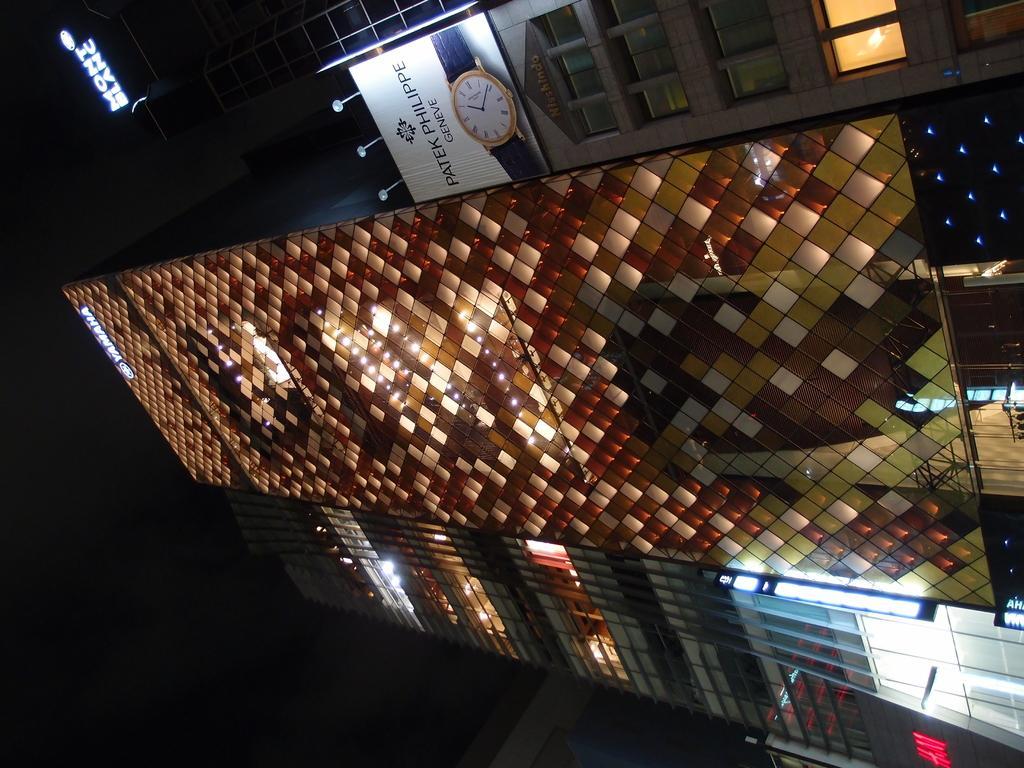How would you summarize this image in a sentence or two? In this image we can see buildings, electric lights, name board and an advertisement. 